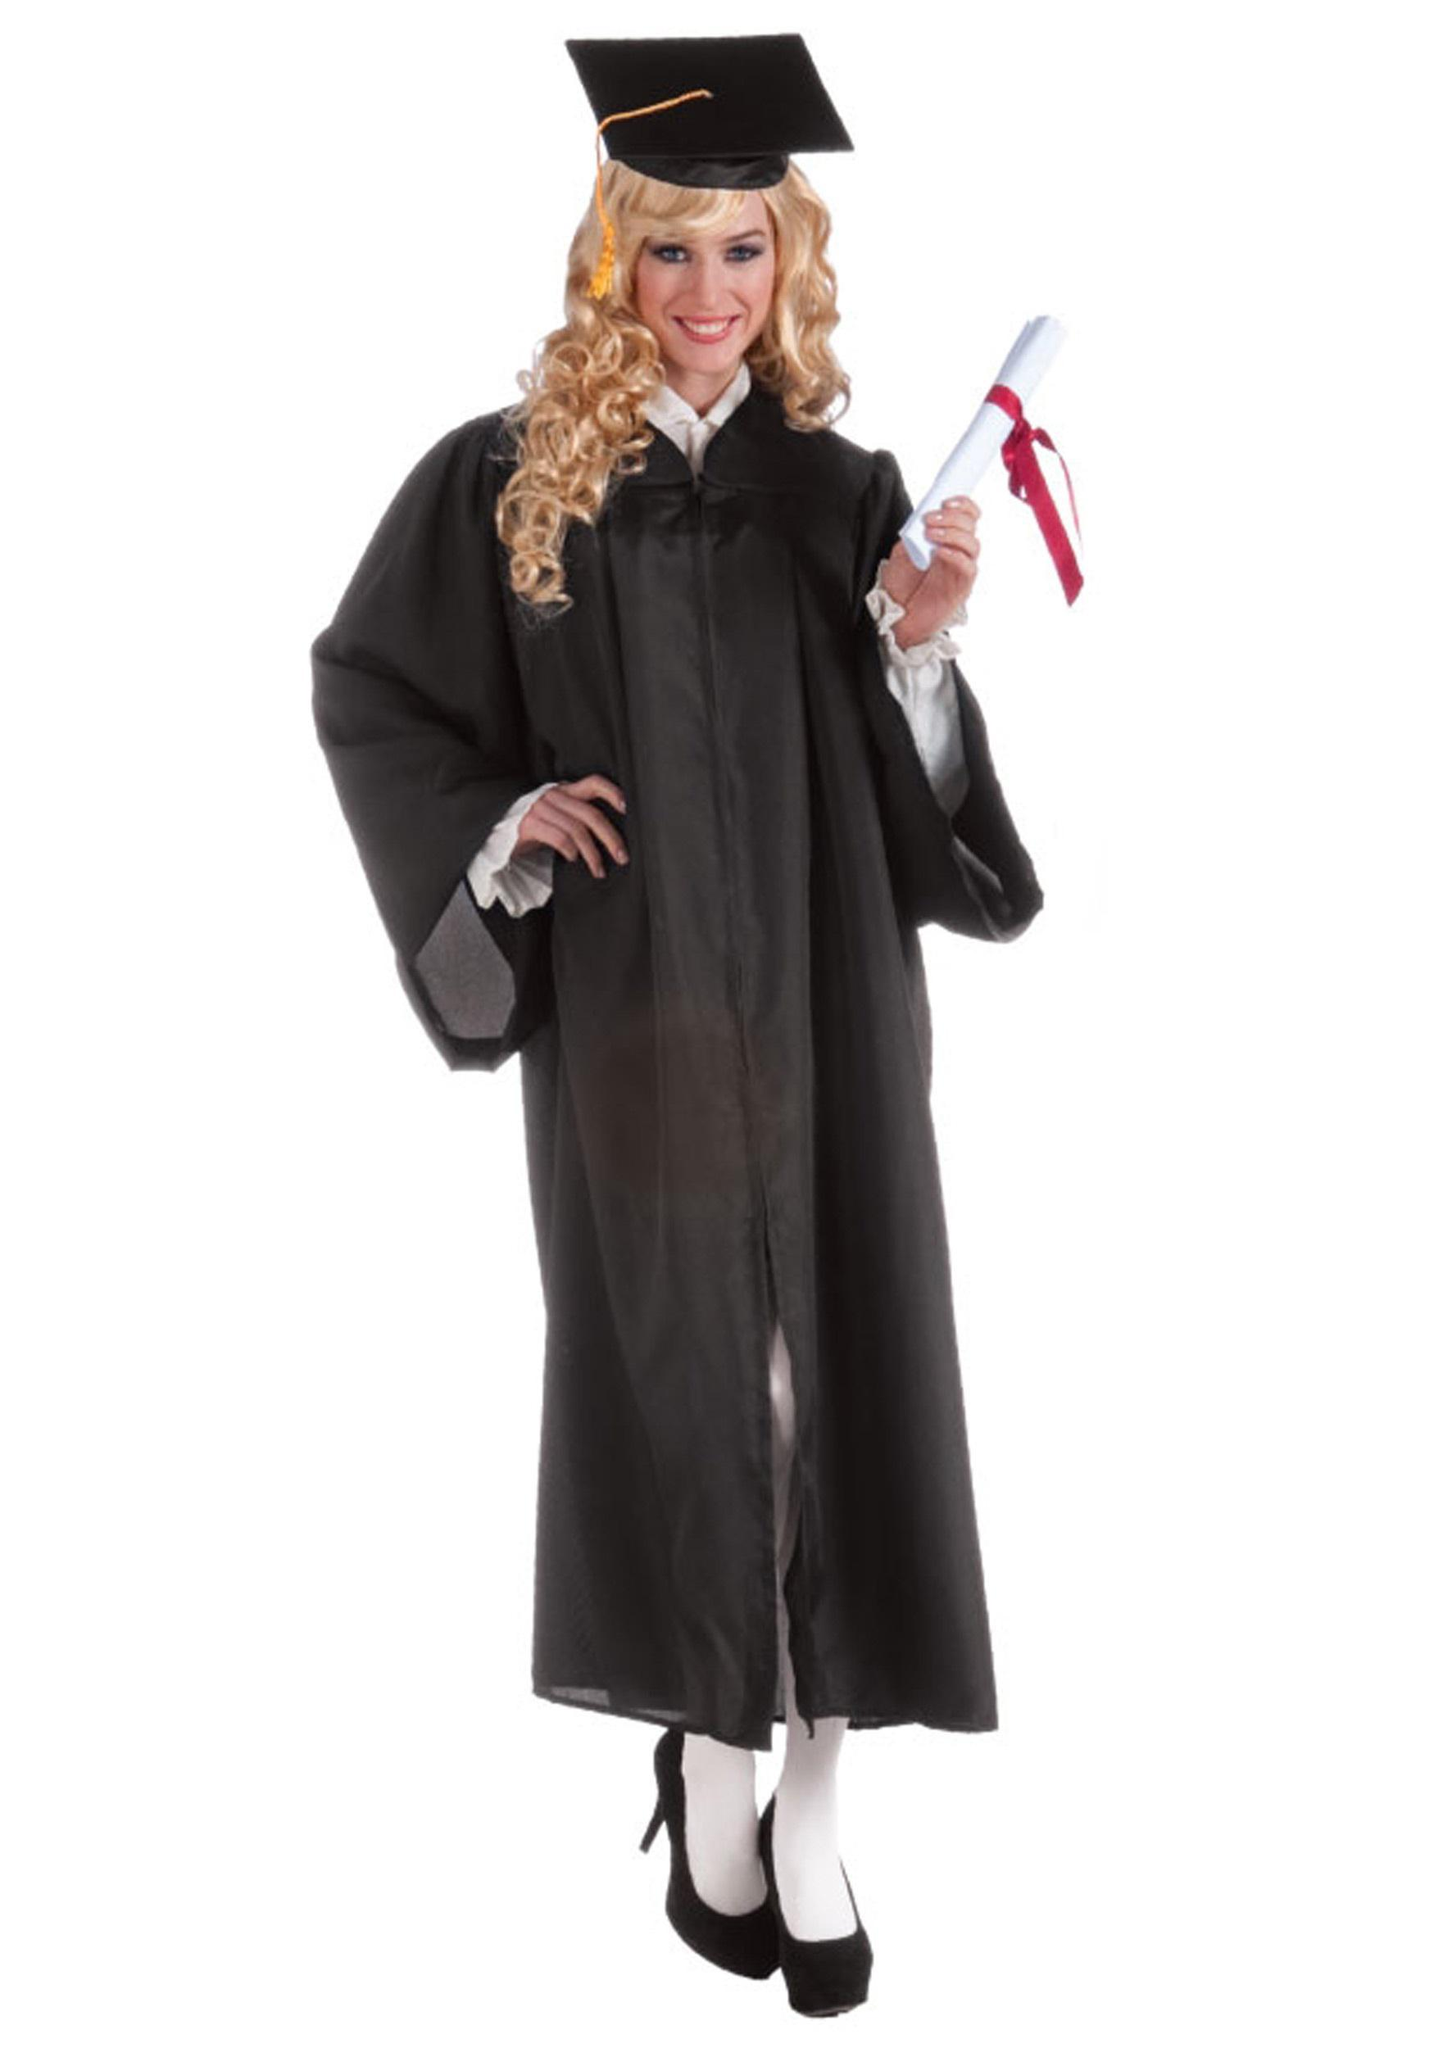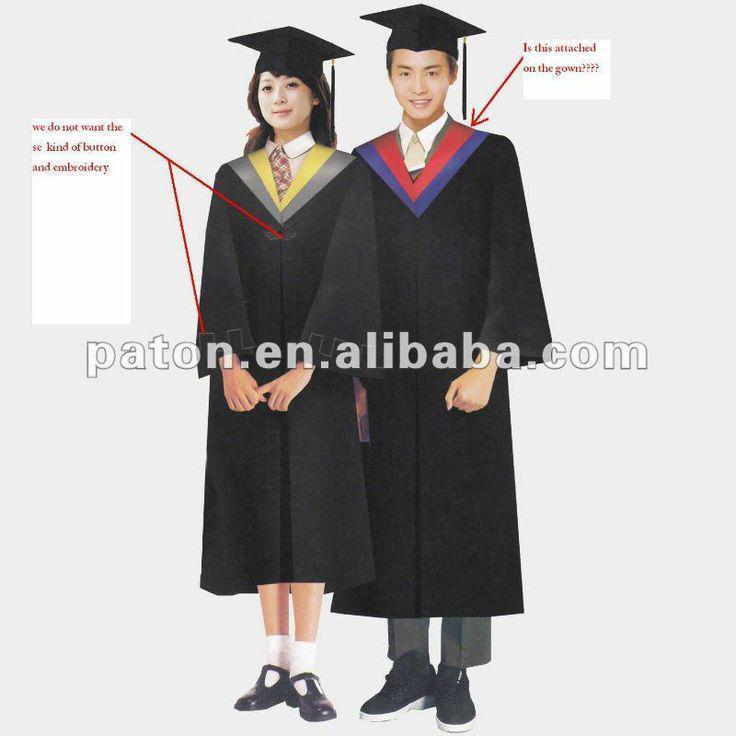The first image is the image on the left, the second image is the image on the right. Examine the images to the left and right. Is the description "Only two different people wearing gowns are visible." accurate? Answer yes or no. No. The first image is the image on the left, the second image is the image on the right. For the images displayed, is the sentence "One of the women has her hand elevated above her elbow." factually correct? Answer yes or no. Yes. 